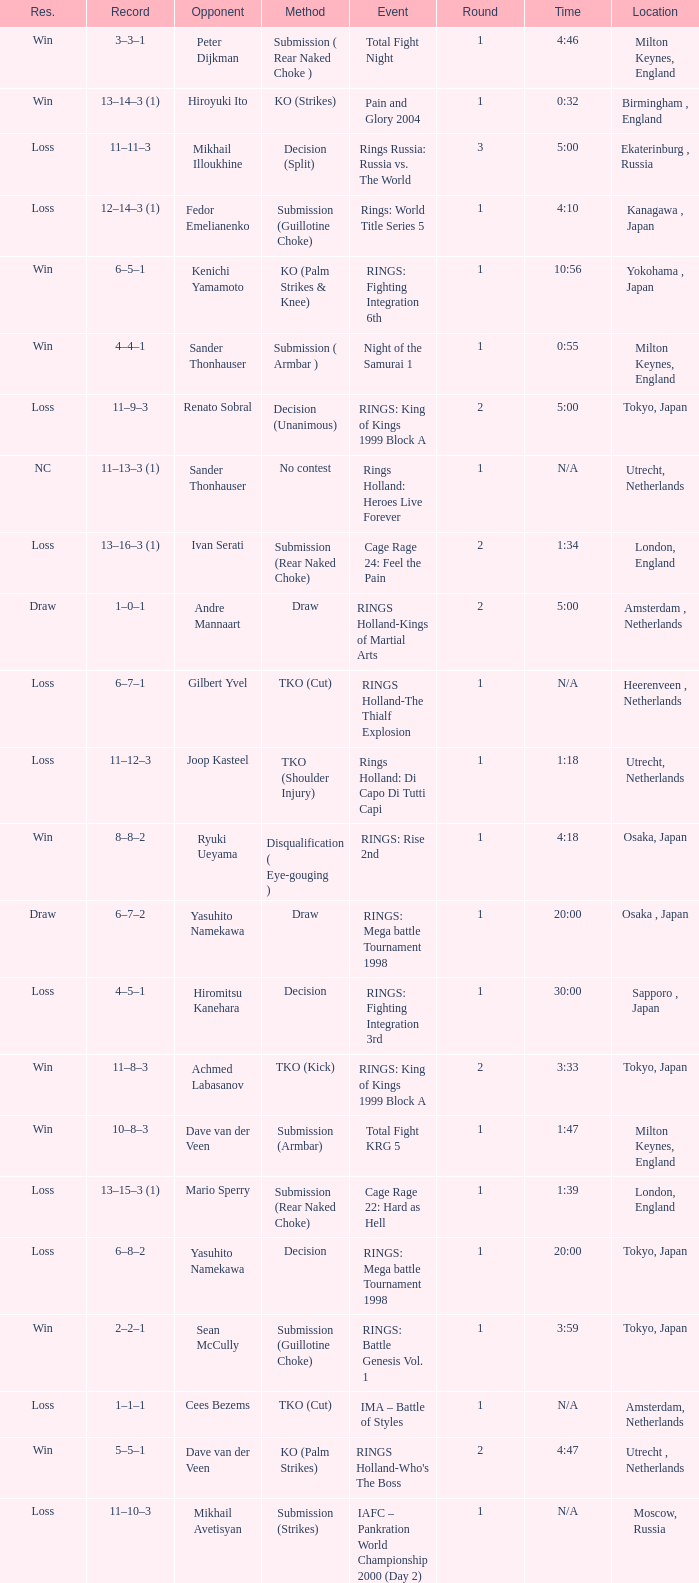What was the method for opponent of Ivan Serati? Submission (Rear Naked Choke). 